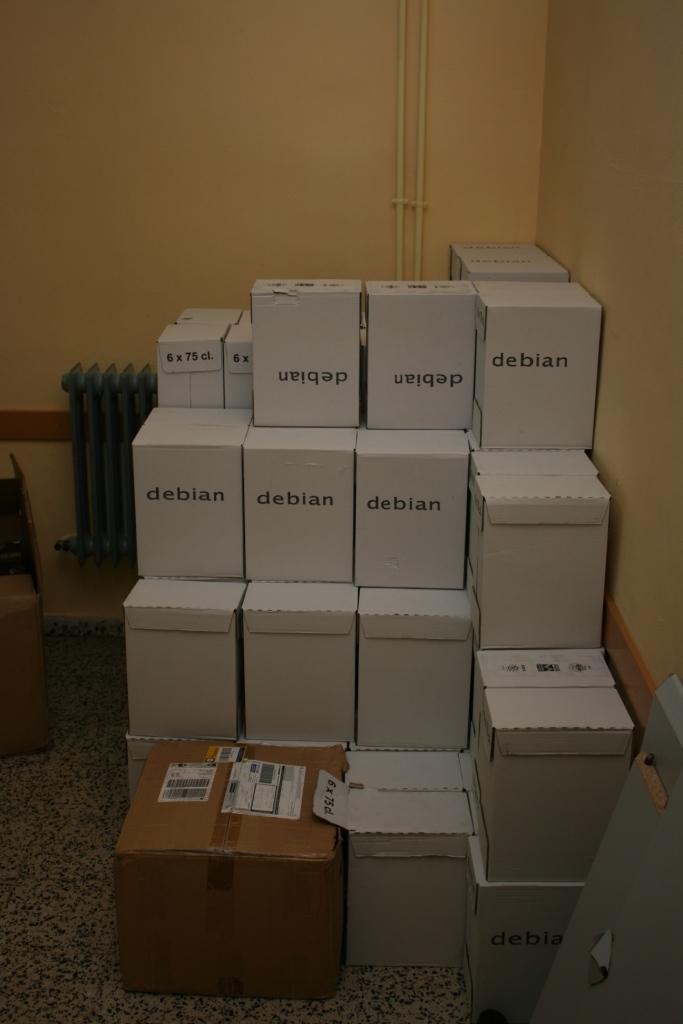<image>
Describe the image concisely. A room displaying numerous white boxes stacked labeled Debian. 